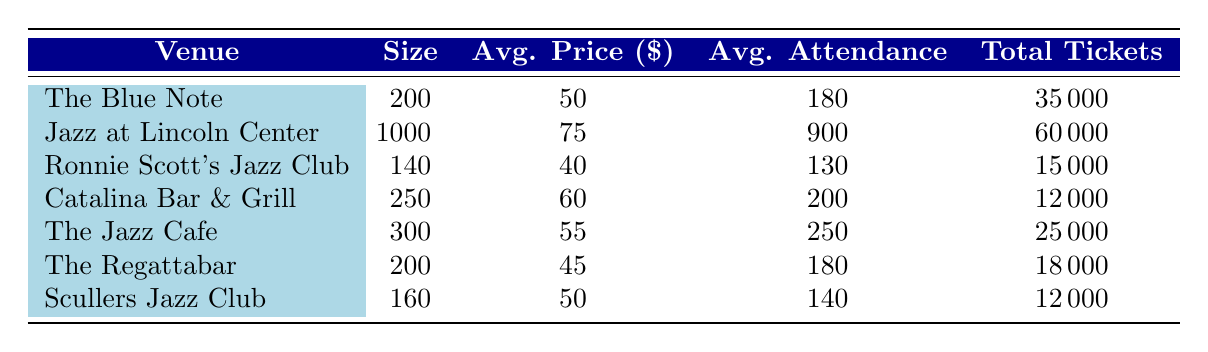What is the total number of tickets sold at "Jazz at Lincoln Center"? Referring to the table, the row for "Jazz at Lincoln Center" shows the value under the "Total Tickets" column as 60000.
Answer: 60000 What is the average ticket price at "Ronnie Scott's Jazz Club"? Checking the row for "Ronnie Scott's Jazz Club," the "Avg. Price" column indicates an average ticket price of 40.
Answer: 40 Is the average attendance at "The Jazz Cafe" greater than 200? Looking at "The Jazz Cafe," the "Avg. Attendance" column shows 250, which is greater than 200. Therefore, the statement is true.
Answer: Yes What is the venue name with the highest average ticket price? By comparing the "Avg. Price" values in all venues, "Jazz at Lincoln Center" has the highest price of 75.
Answer: Jazz at Lincoln Center What is the difference in total tickets sold between "The Blue Note" and "The Regattabar"? The total tickets sold for "The Blue Note" is 35000 and for "The Regattabar" is 18000. The difference is calculated as 35000 - 18000 = 17000.
Answer: 17000 How many venues have a size greater than 200? Reviewing the "Size" column, the venues with sizes greater than 200 are "Jazz at Lincoln Center" (1000), "The Jazz Cafe" (300), and "Catalina Bar & Grill" (250). This totals to 3 venues.
Answer: 3 What is the average venue size across all listed venues? Adding the venue sizes: (200 + 1000 + 140 + 250 + 300 + 200 + 160) = 2250. There are 7 venues, so the average size is 2250 ÷ 7 ≈ 321.43.
Answer: 321.43 Is there a venue that has an average attendance of 180? The rows for "The Blue Note" and "The Regattabar" both show an "Avg. Attendance" of 180. Thus, the answer is yes.
Answer: Yes What is the highest average attendance among all venues? By examining the "Avg. Attendance" column, "Jazz at Lincoln Center" has the highest attendance with 900.
Answer: 900 